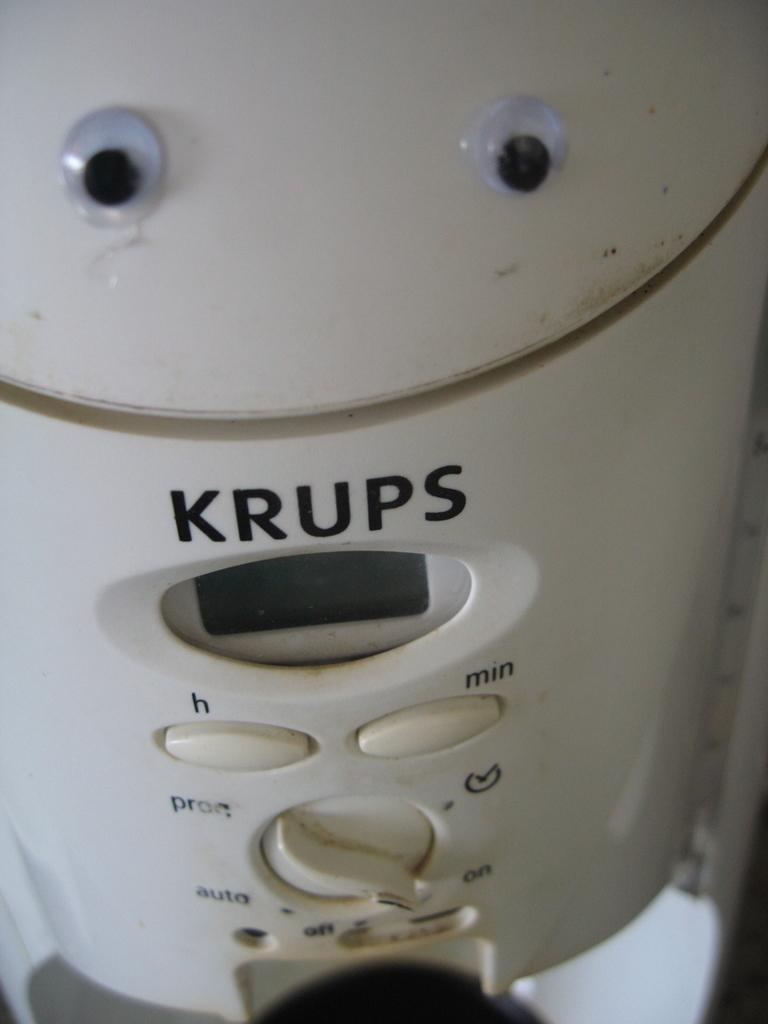What company makes that coffee maker?
Provide a short and direct response. Krups. What is the top right button for?
Provide a succinct answer. Min. 